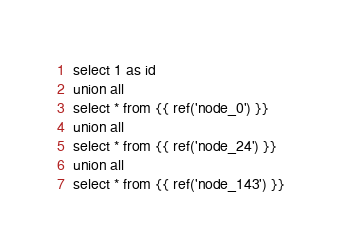Convert code to text. <code><loc_0><loc_0><loc_500><loc_500><_SQL_>select 1 as id
union all
select * from {{ ref('node_0') }}
union all
select * from {{ ref('node_24') }}
union all
select * from {{ ref('node_143') }}</code> 